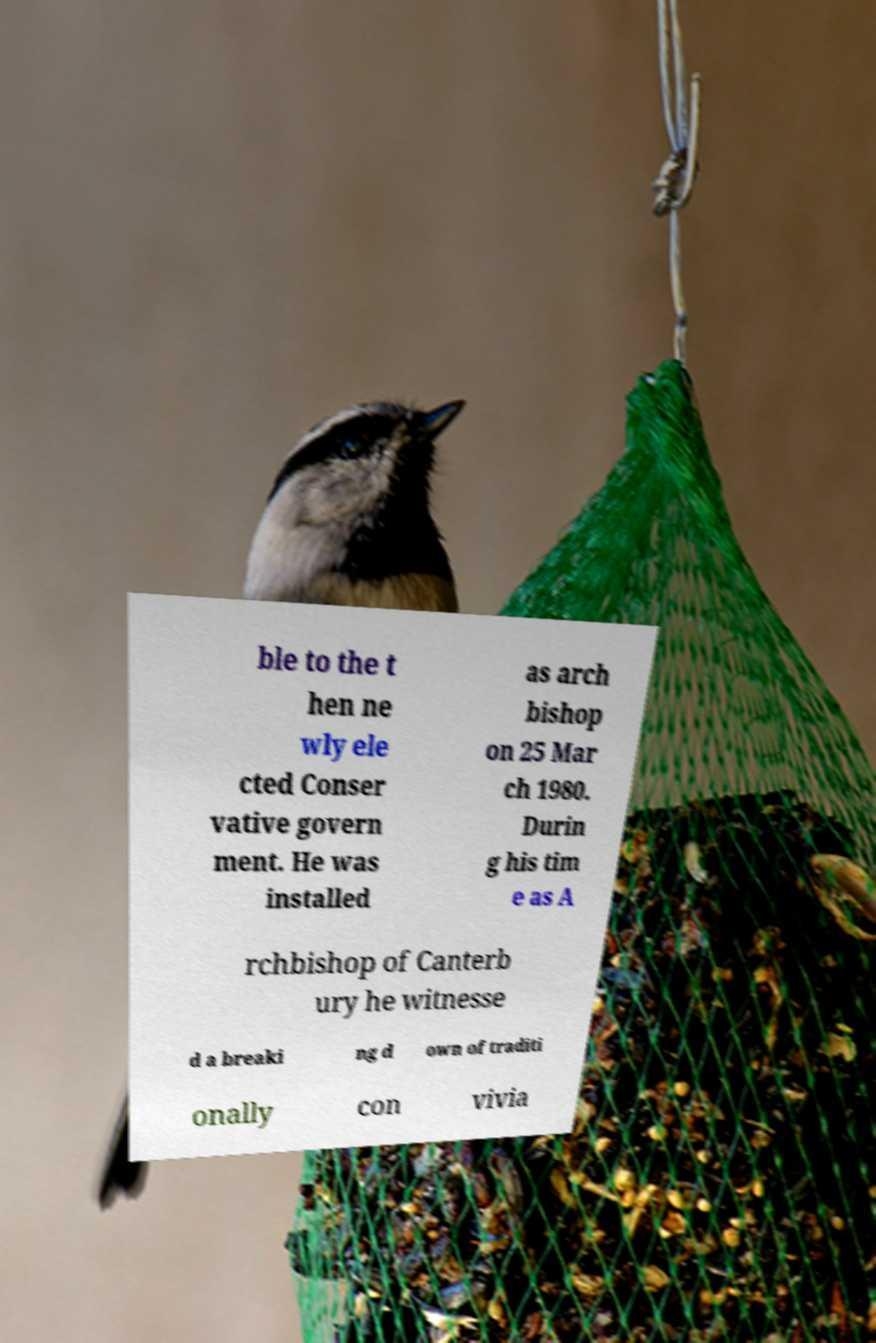Could you assist in decoding the text presented in this image and type it out clearly? ble to the t hen ne wly ele cted Conser vative govern ment. He was installed as arch bishop on 25 Mar ch 1980. Durin g his tim e as A rchbishop of Canterb ury he witnesse d a breaki ng d own of traditi onally con vivia 